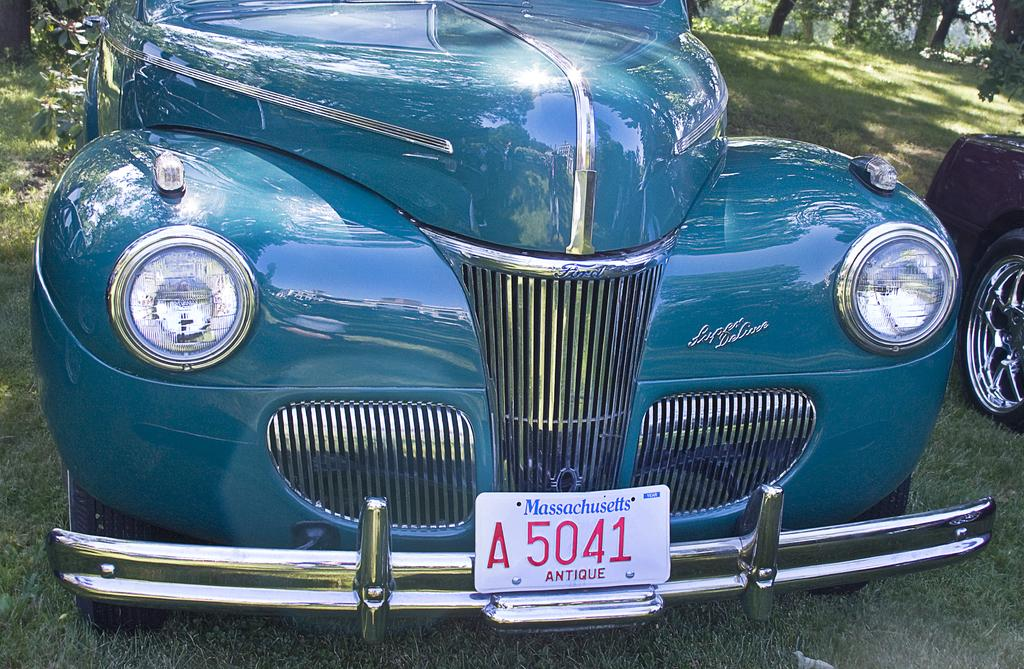What is the location of the car in the image? The car is on the grass in the image. Can you describe any identifying features of the car? The car has a number plate. Which side of the car is visible in the image? A wheel is visible on the right side of the image. What can be seen in the background of the image? There are trees in the background of the image. What type of tin can be seen in the image? There is no tin present in the image. How many mice are visible in the image? There are no mice visible in the image. 